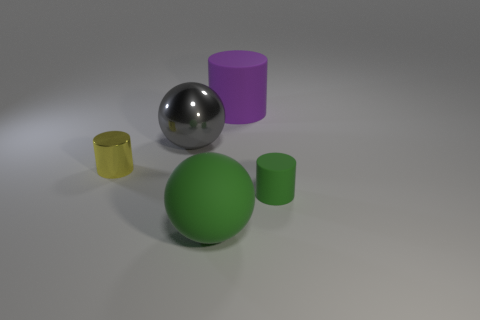Add 3 yellow things. How many objects exist? 8 Subtract all brown cylinders. How many red balls are left? 0 Subtract all gray balls. Subtract all yellow objects. How many objects are left? 3 Add 4 large gray objects. How many large gray objects are left? 5 Add 1 small green rubber cylinders. How many small green rubber cylinders exist? 2 Subtract all yellow cylinders. How many cylinders are left? 2 Subtract all tiny yellow shiny cylinders. How many cylinders are left? 2 Subtract 0 cyan balls. How many objects are left? 5 Subtract all cylinders. How many objects are left? 2 Subtract 1 cylinders. How many cylinders are left? 2 